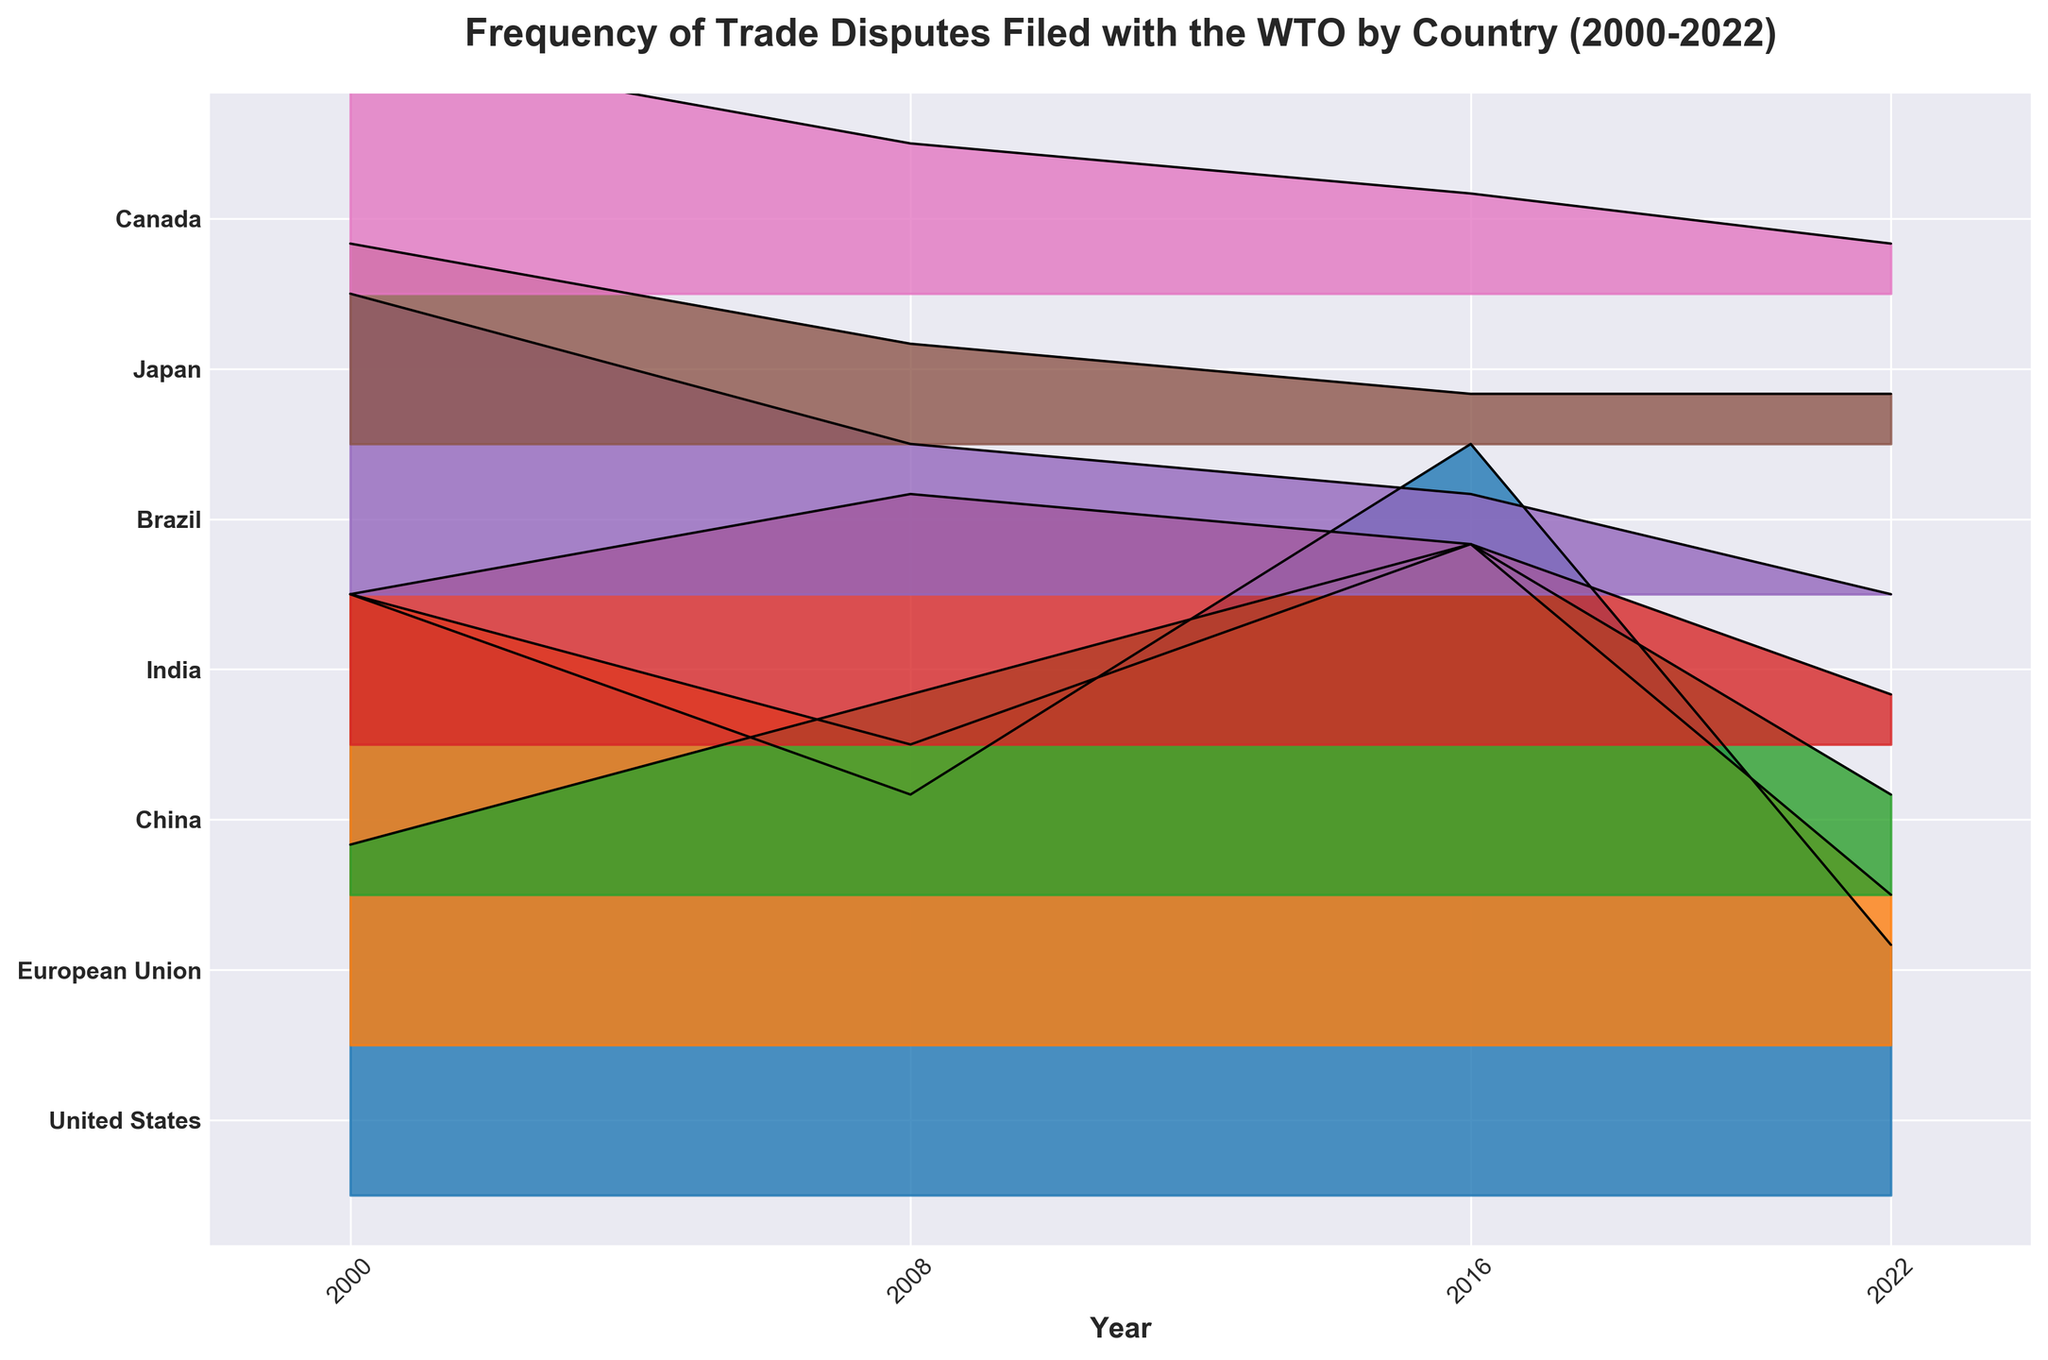What is the title of the plot? The title of the plot is usually located at the top. In this case, the title reads "Frequency of Trade Disputes Filed with the WTO by Country (2000-2022)."
Answer: Frequency of Trade Disputes Filed with the WTO by Country (2000-2022) How many countries are represented in the plot? Count the number of unique country labels on the y-axis. The y-axis lists the countries included in the plot.
Answer: 7 Which country had the highest number of disputes in any given year? Look for the country with the tallest peak in any year. The United States in 2016 has the highest peak, with 15 disputes.
Answer: United States In which year did China file the most disputes? Locate China's ridgeline on the plot and identify the year with the highest peak. According to the plot, China had the most disputes in 2016 with 7 filings.
Answer: 2016 What is the general trend of trade disputes filed by Brazil from 2000 to 2022? Examine Brazil's ridgeline. The height of the ridgeline decreases over the years, showing a downward trend.
Answer: Downward trend How does the number of disputes filed by the European Union in 2000 compare to 2022? Locate the European Union's ridgeline in 2000 and 2022. In 2000, the EU had 9 disputes, while in 2022, it had 3 disputes. This shows a decrease.
Answer: Decrease Which two countries had the exact same number of disputes in 2022? Compare the height of the ridgelines across all countries for the year 2022. Both Japan and Canada had 1 dispute each in 2022.
Answer: Japan and Canada Did the United States or the European Union file more disputes in 2016? Locate the 2016 data points for both the United States and the European Union. The United States filed 15 disputes, whereas the European Union filed 10 disputes.
Answer: United States How many disputes did Canada file from 2000 to 2022? Summarize the number of disputes solely for Canada across all years listed: 5 (2000) + 3 (2008) + 2 (2016) + 1 (2022) = 11 disputes overall.
Answer: 11 Which year had the least number of total disputes filed across all countries? Add up the disputes filed each year and compare. The total for 2022: 5 (US) + 3 (EU) + 2 (China) + 1 (India) + 0 (Brazil) + 1 (Japan) + 1 (Canada) = 13, which is the lowest among all years displayed.
Answer: 2022 